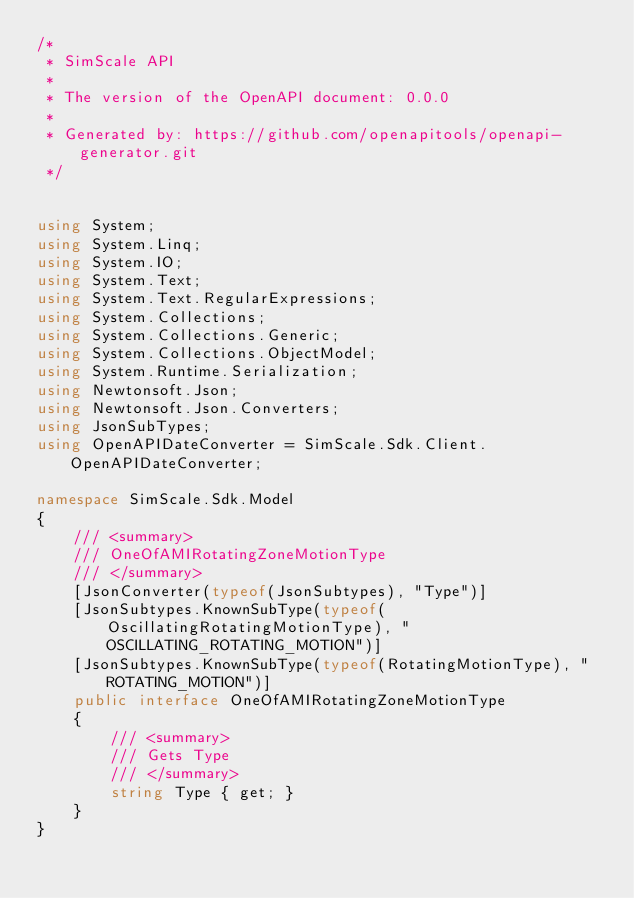Convert code to text. <code><loc_0><loc_0><loc_500><loc_500><_C#_>/* 
 * SimScale API
 *
 * The version of the OpenAPI document: 0.0.0
 * 
 * Generated by: https://github.com/openapitools/openapi-generator.git
 */


using System;
using System.Linq;
using System.IO;
using System.Text;
using System.Text.RegularExpressions;
using System.Collections;
using System.Collections.Generic;
using System.Collections.ObjectModel;
using System.Runtime.Serialization;
using Newtonsoft.Json;
using Newtonsoft.Json.Converters;
using JsonSubTypes;
using OpenAPIDateConverter = SimScale.Sdk.Client.OpenAPIDateConverter;

namespace SimScale.Sdk.Model
{
    /// <summary>
    /// OneOfAMIRotatingZoneMotionType
    /// </summary>
    [JsonConverter(typeof(JsonSubtypes), "Type")]
    [JsonSubtypes.KnownSubType(typeof(OscillatingRotatingMotionType), "OSCILLATING_ROTATING_MOTION")]
    [JsonSubtypes.KnownSubType(typeof(RotatingMotionType), "ROTATING_MOTION")]
    public interface OneOfAMIRotatingZoneMotionType
    {
        /// <summary>
        /// Gets Type
        /// </summary>
        string Type { get; }
    }
}
</code> 